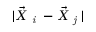Convert formula to latex. <formula><loc_0><loc_0><loc_500><loc_500>| \vec { X } _ { i } - \vec { X } _ { j } |</formula> 